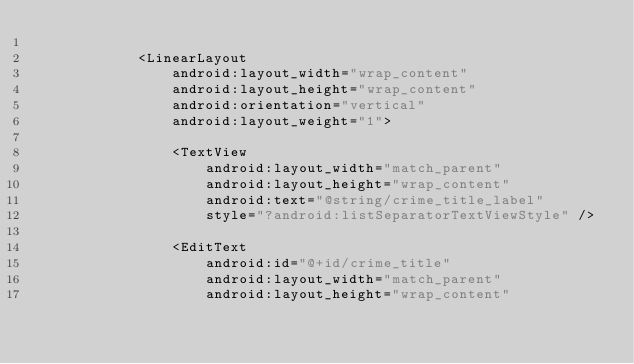Convert code to text. <code><loc_0><loc_0><loc_500><loc_500><_XML_>
            <LinearLayout
                android:layout_width="wrap_content"
                android:layout_height="wrap_content"
                android:orientation="vertical"
                android:layout_weight="1">

                <TextView
                    android:layout_width="match_parent"
                    android:layout_height="wrap_content"
                    android:text="@string/crime_title_label"
                    style="?android:listSeparatorTextViewStyle" />

                <EditText
                    android:id="@+id/crime_title"
                    android:layout_width="match_parent"
                    android:layout_height="wrap_content"</code> 